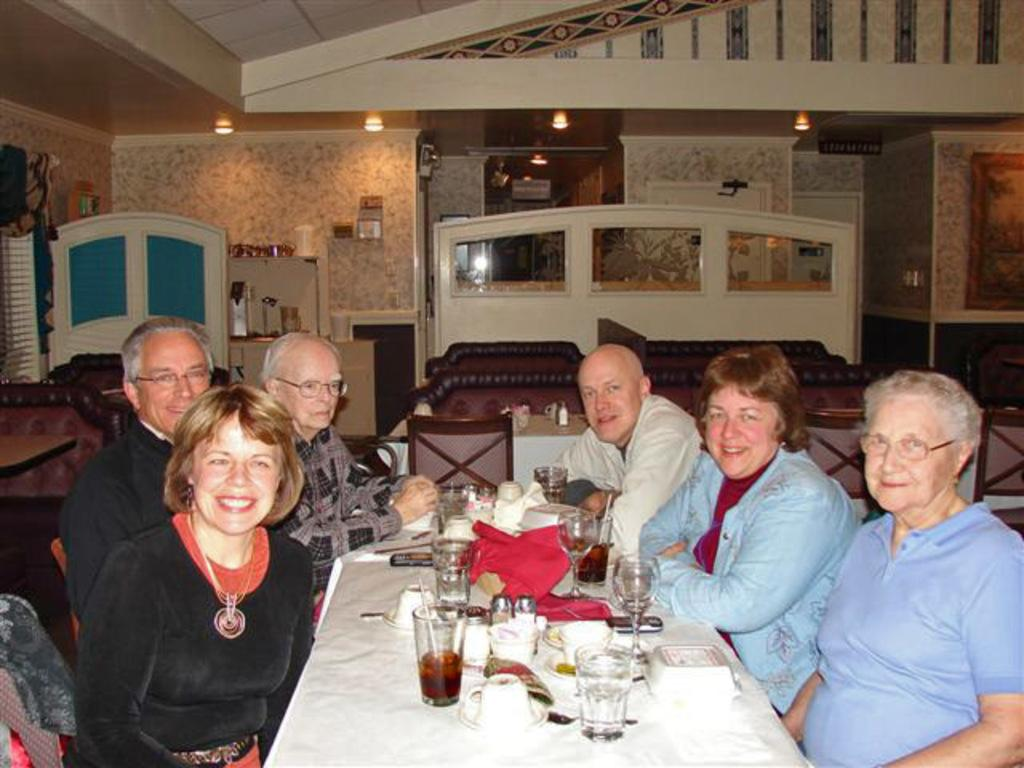How many people are in the image? There is a group of people in the image, but the exact number cannot be determined from the provided facts. What can be seen on the dining table in the image? There are drinks and food on the dining table in the image. What is visible in the background of the image? There is a wall and lights in the background of the image. What type of water is being used to improve the acoustics in the image? There is no mention of water or acoustics in the image, so it cannot be determined if any water is being used for that purpose. 